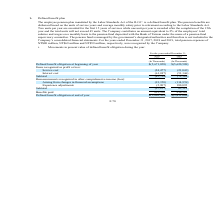According to United Micro Electronics's financial document, The employee pension plan is mandated under which Act? the Labor Standards Act of the R.O.C.. The document states: "The employee pension plan mandated by the Labor Standards Act of the R.O.C. is a defined benefit plan. The pension benefits are disbursed based on the..." Also, What is the criteria for distributing pension benefits? The pension benefits are disbursed based on the units of service years and average monthly salary prior to retirement according to the Labor Standards Act.. The document states: "dards Act of the R.O.C. is a defined benefit plan. The pension benefits are disbursed based on the units of service years and average monthly salary p..." Also, What percentage of amount is contributed to the company in the pension fund of an employee? According to the financial document, 2%. The relevant text states: "s. The Company contributes an amount equivalent to 2% of the employees’ total salaries and wages on a monthly basis to the pension fund deposited with the..." Also, can you calculate: What is the average Service cost? To answer this question, I need to perform calculations using the financial data. The calculation is: (24,477+21,043) / 2, which equals 22760 (in thousands). This is based on the information: "Items recognized as profit or loss: Service cost (24,477) (21,043) Interest cost (61,247) (51,146) Subtotal (85,724) (72,189) Remeasurements recognized in o ognized as profit or loss: Service cost (24..." The key data points involved are: 21,043, 24,477. Also, can you calculate: What is the average interest cost? To answer this question, I need to perform calculations using the financial data. The calculation is: (61,247+51,146) / 2, which equals 56196.5 (in thousands). This is based on the information: "ce cost (24,477) (21,043) Interest cost (61,247) (51,146) Subtotal (85,724) (72,189) Remeasurements recognized in other comprehensive income (loss): Arising ss: Service cost (24,477) (21,043) Interest..." The key data points involved are: 51,146, 61,247. Also, can you calculate: What is the increase/ (decrease) in Benefits paid from 2018 to 2019? Based on the calculation: 216,510-233,530, the result is -17020 (in thousands). This is based on the information: "95 Subtotal (97,257) 65,119 Benefits paid 233,530 216,510 Defined benefit obligation at end of year $(5,620,509) $(5,411,069) 7) 180,095 Subtotal (97,257) 65,119 Benefits paid 233,530 216,510 Defined ..." The key data points involved are: 216,510, 233,530. 